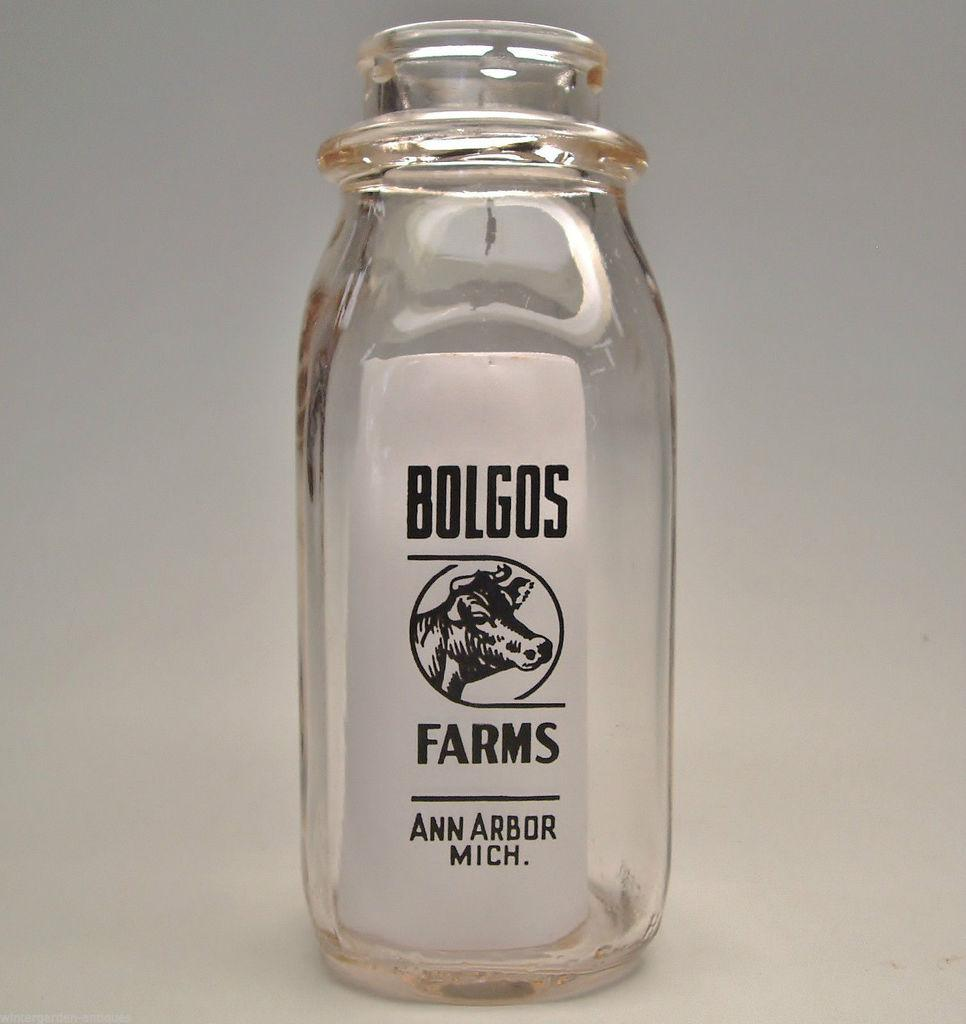What object is placed on the white table in the image? There is a glass bottle on the white table in the image. What is the appearance of the table? The table is white. What is attached to the glass bottle? There is a sticker on the bottle. What information is written on the sticker? The sticker has "Bolgos farms" written on it. Can you see any cactus plants growing on the table in the image? No, there are no cactus plants visible in the image. What type of air is present in the image? The image does not depict air; it shows a glass bottle with a sticker on a white table. 